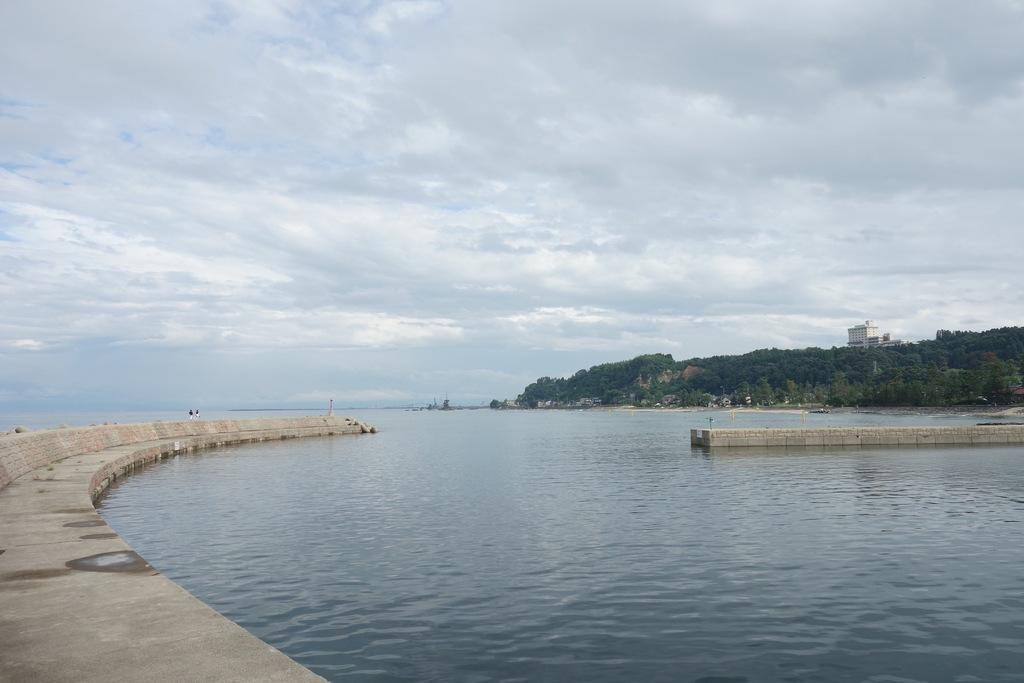Please provide a concise description of this image. In this image we can see sky with clouds, sea, walkway bridge, trees, hills and a building. 